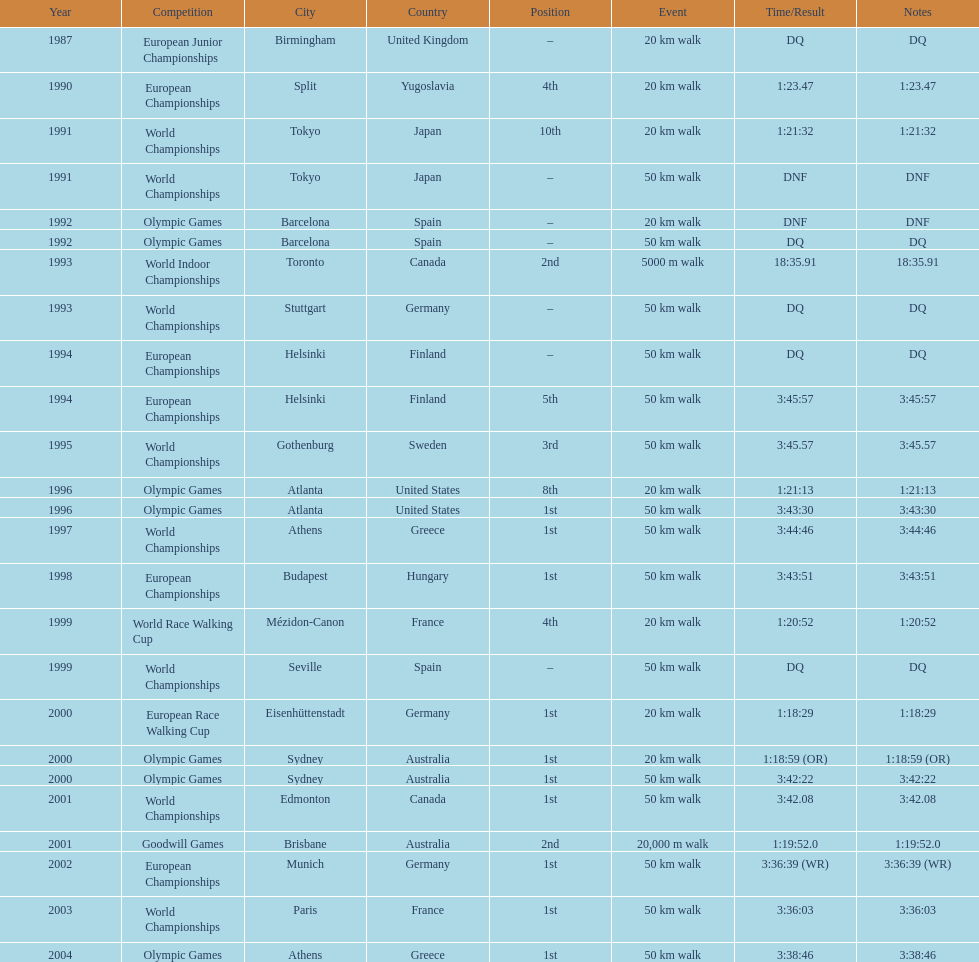How many times was first place listed as the position? 10. 